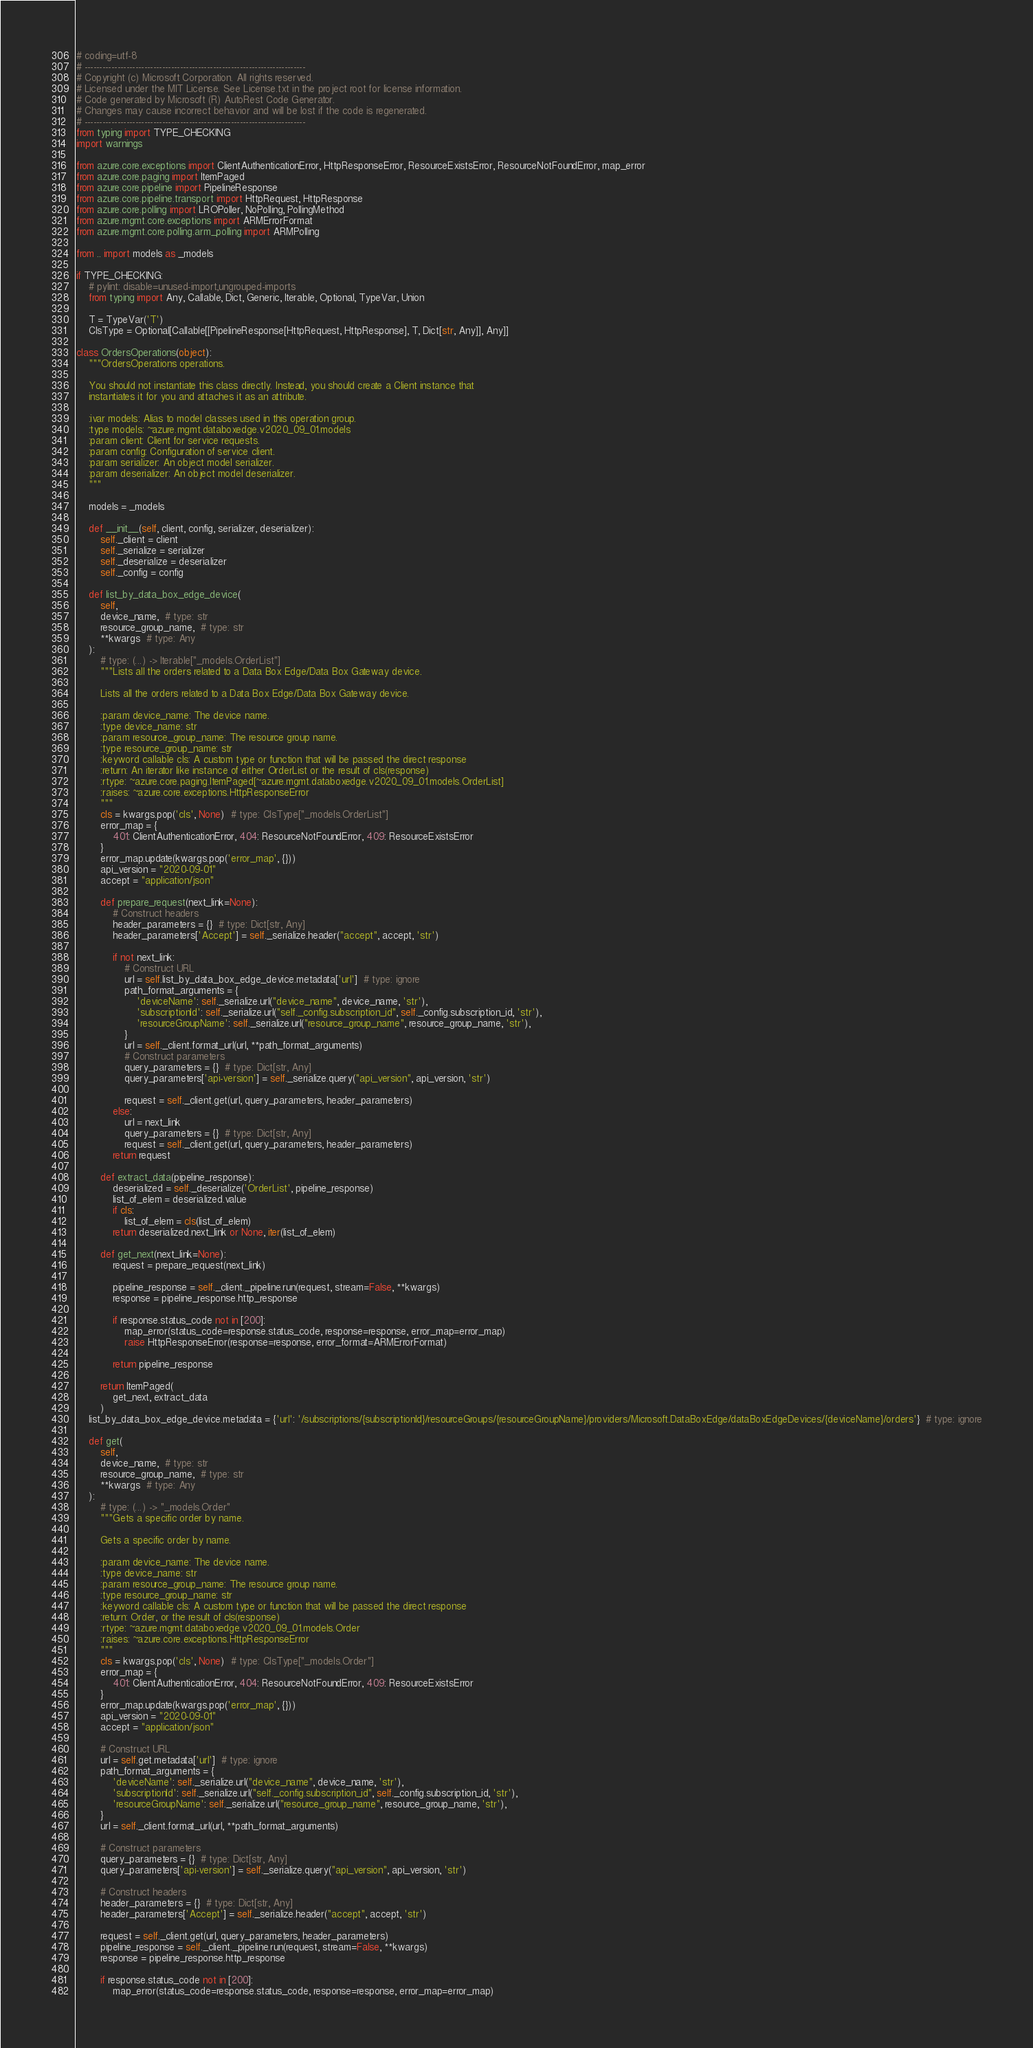<code> <loc_0><loc_0><loc_500><loc_500><_Python_># coding=utf-8
# --------------------------------------------------------------------------
# Copyright (c) Microsoft Corporation. All rights reserved.
# Licensed under the MIT License. See License.txt in the project root for license information.
# Code generated by Microsoft (R) AutoRest Code Generator.
# Changes may cause incorrect behavior and will be lost if the code is regenerated.
# --------------------------------------------------------------------------
from typing import TYPE_CHECKING
import warnings

from azure.core.exceptions import ClientAuthenticationError, HttpResponseError, ResourceExistsError, ResourceNotFoundError, map_error
from azure.core.paging import ItemPaged
from azure.core.pipeline import PipelineResponse
from azure.core.pipeline.transport import HttpRequest, HttpResponse
from azure.core.polling import LROPoller, NoPolling, PollingMethod
from azure.mgmt.core.exceptions import ARMErrorFormat
from azure.mgmt.core.polling.arm_polling import ARMPolling

from .. import models as _models

if TYPE_CHECKING:
    # pylint: disable=unused-import,ungrouped-imports
    from typing import Any, Callable, Dict, Generic, Iterable, Optional, TypeVar, Union

    T = TypeVar('T')
    ClsType = Optional[Callable[[PipelineResponse[HttpRequest, HttpResponse], T, Dict[str, Any]], Any]]

class OrdersOperations(object):
    """OrdersOperations operations.

    You should not instantiate this class directly. Instead, you should create a Client instance that
    instantiates it for you and attaches it as an attribute.

    :ivar models: Alias to model classes used in this operation group.
    :type models: ~azure.mgmt.databoxedge.v2020_09_01.models
    :param client: Client for service requests.
    :param config: Configuration of service client.
    :param serializer: An object model serializer.
    :param deserializer: An object model deserializer.
    """

    models = _models

    def __init__(self, client, config, serializer, deserializer):
        self._client = client
        self._serialize = serializer
        self._deserialize = deserializer
        self._config = config

    def list_by_data_box_edge_device(
        self,
        device_name,  # type: str
        resource_group_name,  # type: str
        **kwargs  # type: Any
    ):
        # type: (...) -> Iterable["_models.OrderList"]
        """Lists all the orders related to a Data Box Edge/Data Box Gateway device.

        Lists all the orders related to a Data Box Edge/Data Box Gateway device.

        :param device_name: The device name.
        :type device_name: str
        :param resource_group_name: The resource group name.
        :type resource_group_name: str
        :keyword callable cls: A custom type or function that will be passed the direct response
        :return: An iterator like instance of either OrderList or the result of cls(response)
        :rtype: ~azure.core.paging.ItemPaged[~azure.mgmt.databoxedge.v2020_09_01.models.OrderList]
        :raises: ~azure.core.exceptions.HttpResponseError
        """
        cls = kwargs.pop('cls', None)  # type: ClsType["_models.OrderList"]
        error_map = {
            401: ClientAuthenticationError, 404: ResourceNotFoundError, 409: ResourceExistsError
        }
        error_map.update(kwargs.pop('error_map', {}))
        api_version = "2020-09-01"
        accept = "application/json"

        def prepare_request(next_link=None):
            # Construct headers
            header_parameters = {}  # type: Dict[str, Any]
            header_parameters['Accept'] = self._serialize.header("accept", accept, 'str')

            if not next_link:
                # Construct URL
                url = self.list_by_data_box_edge_device.metadata['url']  # type: ignore
                path_format_arguments = {
                    'deviceName': self._serialize.url("device_name", device_name, 'str'),
                    'subscriptionId': self._serialize.url("self._config.subscription_id", self._config.subscription_id, 'str'),
                    'resourceGroupName': self._serialize.url("resource_group_name", resource_group_name, 'str'),
                }
                url = self._client.format_url(url, **path_format_arguments)
                # Construct parameters
                query_parameters = {}  # type: Dict[str, Any]
                query_parameters['api-version'] = self._serialize.query("api_version", api_version, 'str')

                request = self._client.get(url, query_parameters, header_parameters)
            else:
                url = next_link
                query_parameters = {}  # type: Dict[str, Any]
                request = self._client.get(url, query_parameters, header_parameters)
            return request

        def extract_data(pipeline_response):
            deserialized = self._deserialize('OrderList', pipeline_response)
            list_of_elem = deserialized.value
            if cls:
                list_of_elem = cls(list_of_elem)
            return deserialized.next_link or None, iter(list_of_elem)

        def get_next(next_link=None):
            request = prepare_request(next_link)

            pipeline_response = self._client._pipeline.run(request, stream=False, **kwargs)
            response = pipeline_response.http_response

            if response.status_code not in [200]:
                map_error(status_code=response.status_code, response=response, error_map=error_map)
                raise HttpResponseError(response=response, error_format=ARMErrorFormat)

            return pipeline_response

        return ItemPaged(
            get_next, extract_data
        )
    list_by_data_box_edge_device.metadata = {'url': '/subscriptions/{subscriptionId}/resourceGroups/{resourceGroupName}/providers/Microsoft.DataBoxEdge/dataBoxEdgeDevices/{deviceName}/orders'}  # type: ignore

    def get(
        self,
        device_name,  # type: str
        resource_group_name,  # type: str
        **kwargs  # type: Any
    ):
        # type: (...) -> "_models.Order"
        """Gets a specific order by name.

        Gets a specific order by name.

        :param device_name: The device name.
        :type device_name: str
        :param resource_group_name: The resource group name.
        :type resource_group_name: str
        :keyword callable cls: A custom type or function that will be passed the direct response
        :return: Order, or the result of cls(response)
        :rtype: ~azure.mgmt.databoxedge.v2020_09_01.models.Order
        :raises: ~azure.core.exceptions.HttpResponseError
        """
        cls = kwargs.pop('cls', None)  # type: ClsType["_models.Order"]
        error_map = {
            401: ClientAuthenticationError, 404: ResourceNotFoundError, 409: ResourceExistsError
        }
        error_map.update(kwargs.pop('error_map', {}))
        api_version = "2020-09-01"
        accept = "application/json"

        # Construct URL
        url = self.get.metadata['url']  # type: ignore
        path_format_arguments = {
            'deviceName': self._serialize.url("device_name", device_name, 'str'),
            'subscriptionId': self._serialize.url("self._config.subscription_id", self._config.subscription_id, 'str'),
            'resourceGroupName': self._serialize.url("resource_group_name", resource_group_name, 'str'),
        }
        url = self._client.format_url(url, **path_format_arguments)

        # Construct parameters
        query_parameters = {}  # type: Dict[str, Any]
        query_parameters['api-version'] = self._serialize.query("api_version", api_version, 'str')

        # Construct headers
        header_parameters = {}  # type: Dict[str, Any]
        header_parameters['Accept'] = self._serialize.header("accept", accept, 'str')

        request = self._client.get(url, query_parameters, header_parameters)
        pipeline_response = self._client._pipeline.run(request, stream=False, **kwargs)
        response = pipeline_response.http_response

        if response.status_code not in [200]:
            map_error(status_code=response.status_code, response=response, error_map=error_map)</code> 